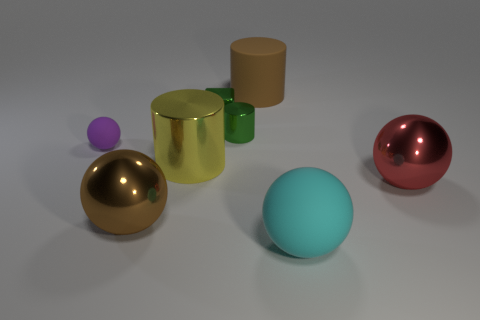Is the size of the brown thing on the left side of the yellow thing the same as the red sphere?
Your answer should be compact. Yes. How many red spheres are behind the brown metallic object?
Your answer should be very brief. 1. Are there any cubes of the same size as the purple rubber thing?
Provide a short and direct response. Yes. Is the small cube the same color as the small metallic cylinder?
Make the answer very short. Yes. What color is the big thing that is on the left side of the metallic cylinder that is left of the green cylinder?
Provide a short and direct response. Brown. What number of balls are left of the red metal object and on the right side of the large brown matte cylinder?
Provide a succinct answer. 1. What number of cyan objects are the same shape as the large brown shiny object?
Ensure brevity in your answer.  1. Do the small sphere and the small cylinder have the same material?
Make the answer very short. No. What shape is the thing in front of the shiny ball that is to the left of the matte cylinder?
Provide a succinct answer. Sphere. There is a rubber ball that is behind the cyan matte sphere; how many green cubes are in front of it?
Offer a terse response. 0. 